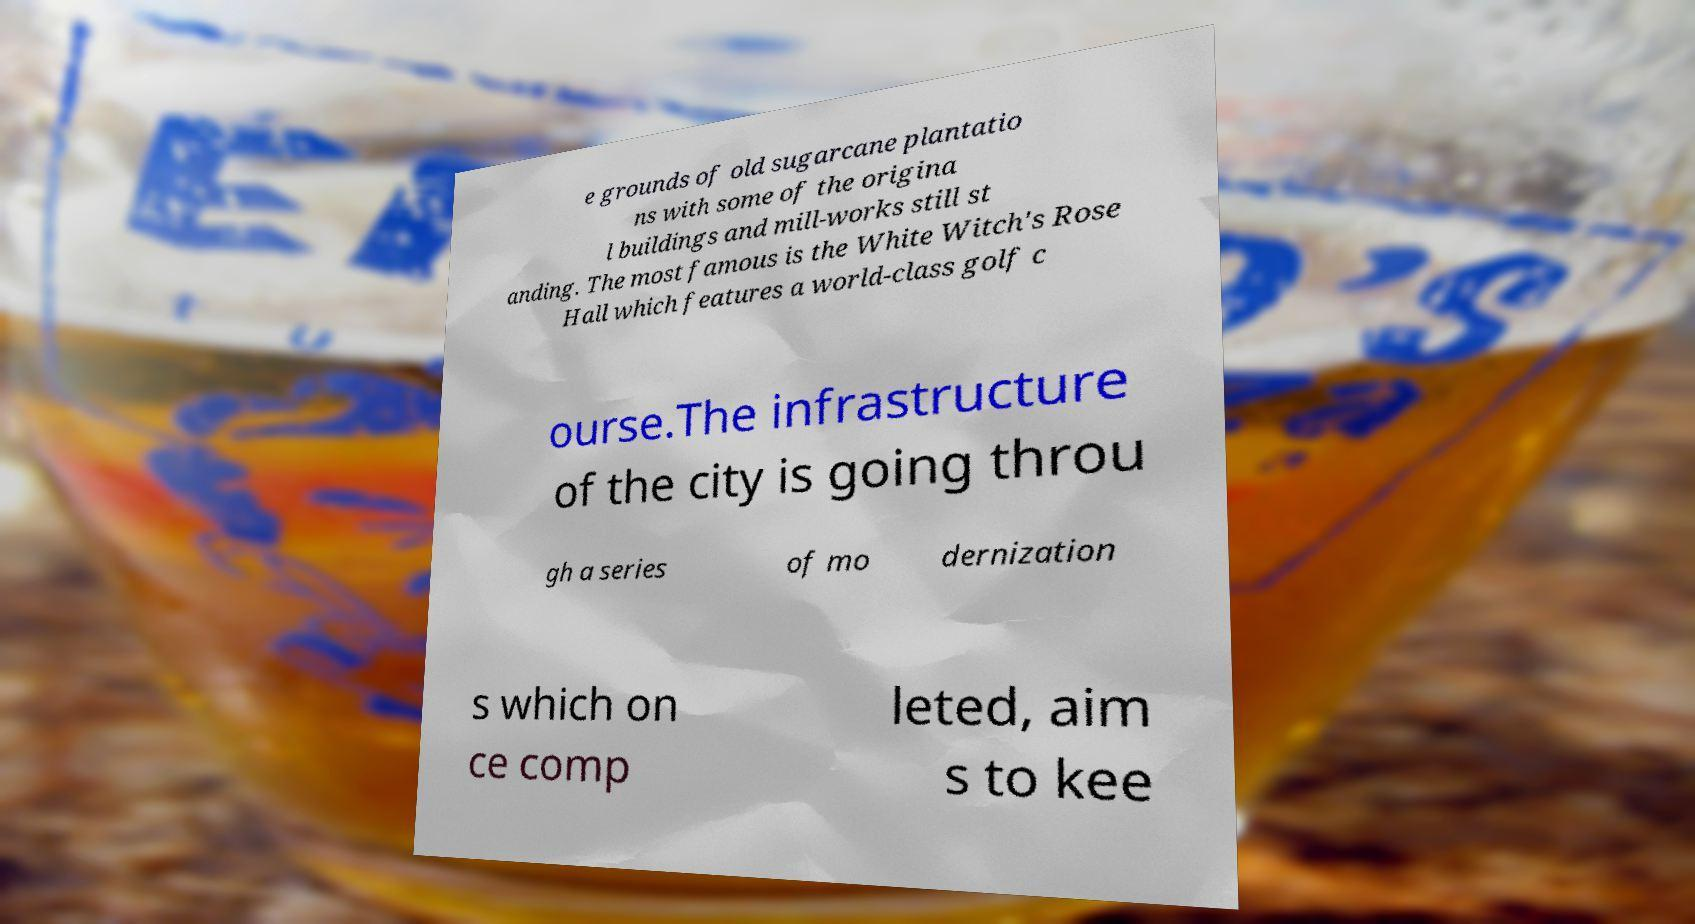Can you read and provide the text displayed in the image?This photo seems to have some interesting text. Can you extract and type it out for me? e grounds of old sugarcane plantatio ns with some of the origina l buildings and mill-works still st anding. The most famous is the White Witch's Rose Hall which features a world-class golf c ourse.The infrastructure of the city is going throu gh a series of mo dernization s which on ce comp leted, aim s to kee 